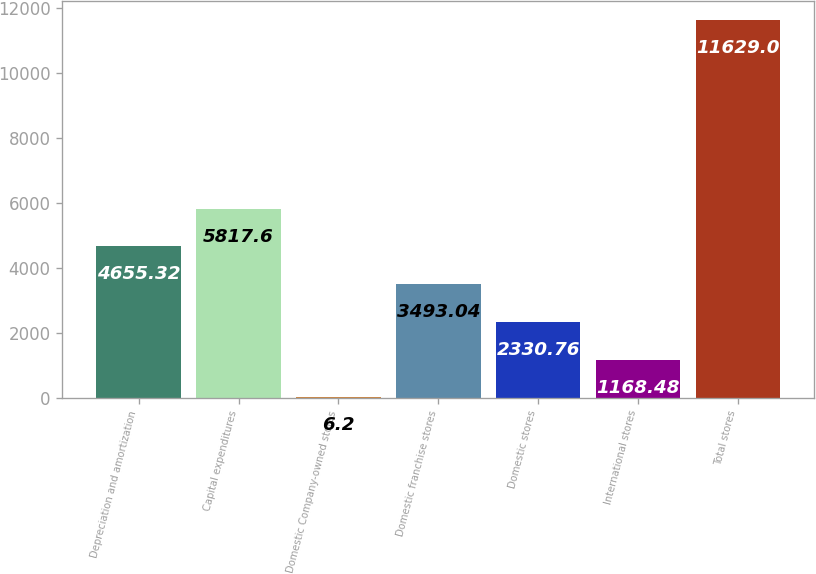Convert chart to OTSL. <chart><loc_0><loc_0><loc_500><loc_500><bar_chart><fcel>Depreciation and amortization<fcel>Capital expenditures<fcel>Domestic Company-owned stores<fcel>Domestic franchise stores<fcel>Domestic stores<fcel>International stores<fcel>Total stores<nl><fcel>4655.32<fcel>5817.6<fcel>6.2<fcel>3493.04<fcel>2330.76<fcel>1168.48<fcel>11629<nl></chart> 